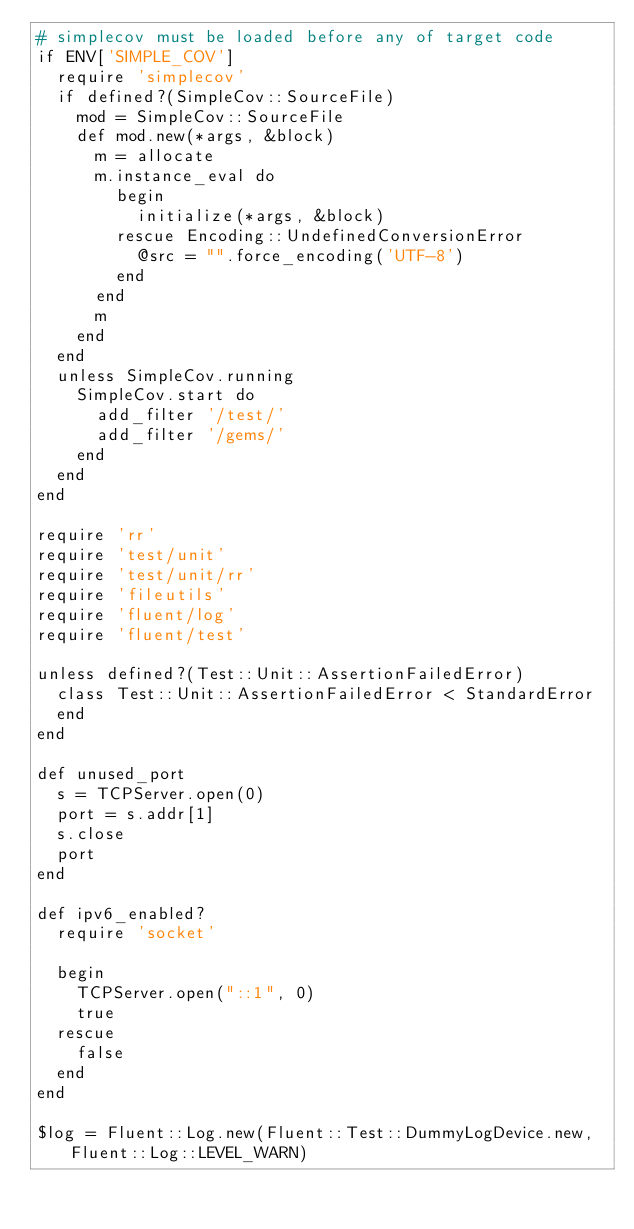Convert code to text. <code><loc_0><loc_0><loc_500><loc_500><_Ruby_># simplecov must be loaded before any of target code
if ENV['SIMPLE_COV']
  require 'simplecov'
  if defined?(SimpleCov::SourceFile)
    mod = SimpleCov::SourceFile
    def mod.new(*args, &block)
      m = allocate
      m.instance_eval do
        begin
          initialize(*args, &block)
        rescue Encoding::UndefinedConversionError
          @src = "".force_encoding('UTF-8')
        end
      end
      m
    end
  end
  unless SimpleCov.running
    SimpleCov.start do
      add_filter '/test/'
      add_filter '/gems/'
    end
  end
end

require 'rr'
require 'test/unit'
require 'test/unit/rr'
require 'fileutils'
require 'fluent/log'
require 'fluent/test'

unless defined?(Test::Unit::AssertionFailedError)
  class Test::Unit::AssertionFailedError < StandardError
  end
end

def unused_port
  s = TCPServer.open(0)
  port = s.addr[1]
  s.close
  port
end

def ipv6_enabled?
  require 'socket'

  begin
    TCPServer.open("::1", 0)
    true
  rescue
    false
  end
end

$log = Fluent::Log.new(Fluent::Test::DummyLogDevice.new, Fluent::Log::LEVEL_WARN)
</code> 